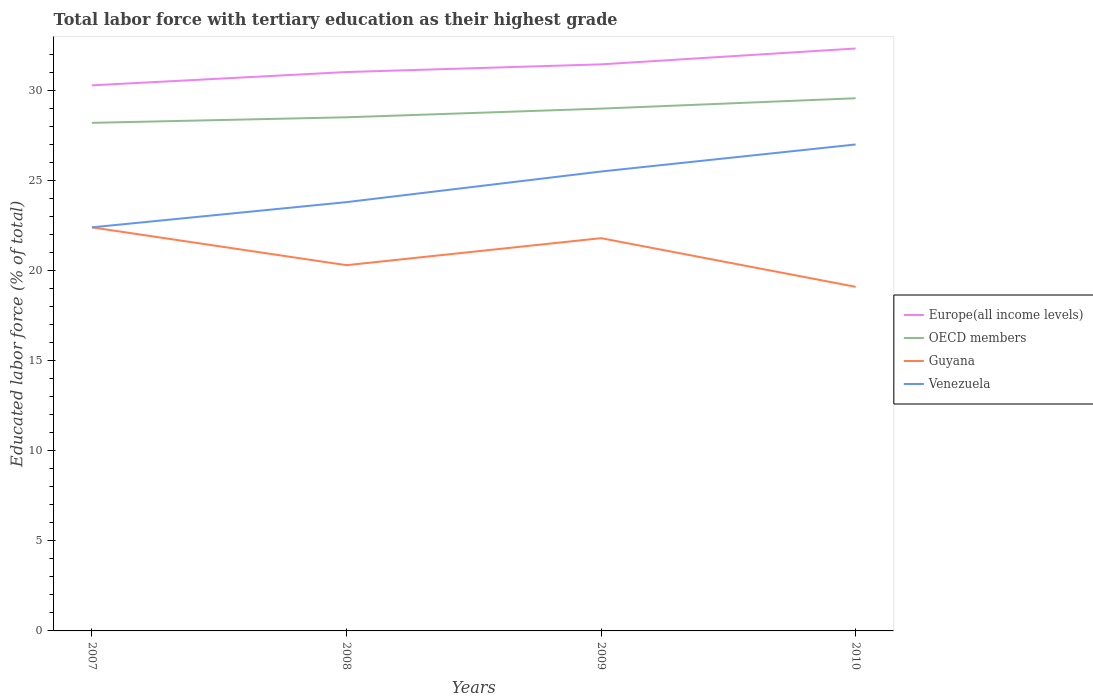Does the line corresponding to OECD members intersect with the line corresponding to Guyana?
Your answer should be very brief. No. Is the number of lines equal to the number of legend labels?
Keep it short and to the point. Yes. Across all years, what is the maximum percentage of male labor force with tertiary education in Guyana?
Ensure brevity in your answer.  19.1. In which year was the percentage of male labor force with tertiary education in Guyana maximum?
Ensure brevity in your answer.  2010. What is the total percentage of male labor force with tertiary education in Guyana in the graph?
Provide a short and direct response. 2.1. What is the difference between the highest and the second highest percentage of male labor force with tertiary education in OECD members?
Your response must be concise. 1.36. What is the difference between the highest and the lowest percentage of male labor force with tertiary education in Guyana?
Ensure brevity in your answer.  2. How many lines are there?
Offer a very short reply. 4. What is the difference between two consecutive major ticks on the Y-axis?
Your response must be concise. 5. Are the values on the major ticks of Y-axis written in scientific E-notation?
Give a very brief answer. No. Does the graph contain grids?
Offer a very short reply. No. Where does the legend appear in the graph?
Provide a succinct answer. Center right. How many legend labels are there?
Your response must be concise. 4. How are the legend labels stacked?
Make the answer very short. Vertical. What is the title of the graph?
Offer a very short reply. Total labor force with tertiary education as their highest grade. What is the label or title of the Y-axis?
Give a very brief answer. Educated labor force (% of total). What is the Educated labor force (% of total) in Europe(all income levels) in 2007?
Offer a very short reply. 30.28. What is the Educated labor force (% of total) of OECD members in 2007?
Give a very brief answer. 28.2. What is the Educated labor force (% of total) in Guyana in 2007?
Offer a terse response. 22.4. What is the Educated labor force (% of total) in Venezuela in 2007?
Provide a short and direct response. 22.4. What is the Educated labor force (% of total) in Europe(all income levels) in 2008?
Make the answer very short. 31.02. What is the Educated labor force (% of total) in OECD members in 2008?
Your answer should be very brief. 28.51. What is the Educated labor force (% of total) in Guyana in 2008?
Your response must be concise. 20.3. What is the Educated labor force (% of total) in Venezuela in 2008?
Your answer should be compact. 23.8. What is the Educated labor force (% of total) in Europe(all income levels) in 2009?
Provide a succinct answer. 31.45. What is the Educated labor force (% of total) of OECD members in 2009?
Provide a succinct answer. 28.99. What is the Educated labor force (% of total) in Guyana in 2009?
Your response must be concise. 21.8. What is the Educated labor force (% of total) of Venezuela in 2009?
Give a very brief answer. 25.5. What is the Educated labor force (% of total) of Europe(all income levels) in 2010?
Give a very brief answer. 32.33. What is the Educated labor force (% of total) of OECD members in 2010?
Keep it short and to the point. 29.57. What is the Educated labor force (% of total) of Guyana in 2010?
Ensure brevity in your answer.  19.1. Across all years, what is the maximum Educated labor force (% of total) in Europe(all income levels)?
Offer a very short reply. 32.33. Across all years, what is the maximum Educated labor force (% of total) in OECD members?
Give a very brief answer. 29.57. Across all years, what is the maximum Educated labor force (% of total) in Guyana?
Offer a very short reply. 22.4. Across all years, what is the maximum Educated labor force (% of total) of Venezuela?
Your response must be concise. 27. Across all years, what is the minimum Educated labor force (% of total) of Europe(all income levels)?
Give a very brief answer. 30.28. Across all years, what is the minimum Educated labor force (% of total) of OECD members?
Offer a terse response. 28.2. Across all years, what is the minimum Educated labor force (% of total) of Guyana?
Keep it short and to the point. 19.1. Across all years, what is the minimum Educated labor force (% of total) in Venezuela?
Ensure brevity in your answer.  22.4. What is the total Educated labor force (% of total) of Europe(all income levels) in the graph?
Provide a short and direct response. 125.08. What is the total Educated labor force (% of total) of OECD members in the graph?
Offer a very short reply. 115.27. What is the total Educated labor force (% of total) in Guyana in the graph?
Your answer should be very brief. 83.6. What is the total Educated labor force (% of total) in Venezuela in the graph?
Your answer should be very brief. 98.7. What is the difference between the Educated labor force (% of total) of Europe(all income levels) in 2007 and that in 2008?
Ensure brevity in your answer.  -0.74. What is the difference between the Educated labor force (% of total) of OECD members in 2007 and that in 2008?
Offer a terse response. -0.31. What is the difference between the Educated labor force (% of total) in Europe(all income levels) in 2007 and that in 2009?
Offer a very short reply. -1.16. What is the difference between the Educated labor force (% of total) of OECD members in 2007 and that in 2009?
Give a very brief answer. -0.79. What is the difference between the Educated labor force (% of total) of Europe(all income levels) in 2007 and that in 2010?
Provide a succinct answer. -2.04. What is the difference between the Educated labor force (% of total) in OECD members in 2007 and that in 2010?
Make the answer very short. -1.36. What is the difference between the Educated labor force (% of total) of Europe(all income levels) in 2008 and that in 2009?
Your answer should be very brief. -0.43. What is the difference between the Educated labor force (% of total) in OECD members in 2008 and that in 2009?
Keep it short and to the point. -0.48. What is the difference between the Educated labor force (% of total) in Guyana in 2008 and that in 2009?
Your answer should be very brief. -1.5. What is the difference between the Educated labor force (% of total) of Venezuela in 2008 and that in 2009?
Offer a very short reply. -1.7. What is the difference between the Educated labor force (% of total) of Europe(all income levels) in 2008 and that in 2010?
Make the answer very short. -1.31. What is the difference between the Educated labor force (% of total) of OECD members in 2008 and that in 2010?
Provide a short and direct response. -1.06. What is the difference between the Educated labor force (% of total) in Europe(all income levels) in 2009 and that in 2010?
Keep it short and to the point. -0.88. What is the difference between the Educated labor force (% of total) in OECD members in 2009 and that in 2010?
Your answer should be very brief. -0.58. What is the difference between the Educated labor force (% of total) in Guyana in 2009 and that in 2010?
Your answer should be very brief. 2.7. What is the difference between the Educated labor force (% of total) of Venezuela in 2009 and that in 2010?
Provide a short and direct response. -1.5. What is the difference between the Educated labor force (% of total) of Europe(all income levels) in 2007 and the Educated labor force (% of total) of OECD members in 2008?
Your response must be concise. 1.77. What is the difference between the Educated labor force (% of total) in Europe(all income levels) in 2007 and the Educated labor force (% of total) in Guyana in 2008?
Keep it short and to the point. 9.98. What is the difference between the Educated labor force (% of total) of Europe(all income levels) in 2007 and the Educated labor force (% of total) of Venezuela in 2008?
Your answer should be compact. 6.48. What is the difference between the Educated labor force (% of total) of OECD members in 2007 and the Educated labor force (% of total) of Guyana in 2008?
Ensure brevity in your answer.  7.9. What is the difference between the Educated labor force (% of total) in OECD members in 2007 and the Educated labor force (% of total) in Venezuela in 2008?
Provide a succinct answer. 4.4. What is the difference between the Educated labor force (% of total) in Guyana in 2007 and the Educated labor force (% of total) in Venezuela in 2008?
Offer a terse response. -1.4. What is the difference between the Educated labor force (% of total) of Europe(all income levels) in 2007 and the Educated labor force (% of total) of OECD members in 2009?
Offer a very short reply. 1.29. What is the difference between the Educated labor force (% of total) in Europe(all income levels) in 2007 and the Educated labor force (% of total) in Guyana in 2009?
Your response must be concise. 8.48. What is the difference between the Educated labor force (% of total) in Europe(all income levels) in 2007 and the Educated labor force (% of total) in Venezuela in 2009?
Make the answer very short. 4.78. What is the difference between the Educated labor force (% of total) of OECD members in 2007 and the Educated labor force (% of total) of Guyana in 2009?
Your answer should be compact. 6.4. What is the difference between the Educated labor force (% of total) in OECD members in 2007 and the Educated labor force (% of total) in Venezuela in 2009?
Keep it short and to the point. 2.7. What is the difference between the Educated labor force (% of total) in Europe(all income levels) in 2007 and the Educated labor force (% of total) in OECD members in 2010?
Provide a succinct answer. 0.72. What is the difference between the Educated labor force (% of total) of Europe(all income levels) in 2007 and the Educated labor force (% of total) of Guyana in 2010?
Provide a succinct answer. 11.18. What is the difference between the Educated labor force (% of total) of Europe(all income levels) in 2007 and the Educated labor force (% of total) of Venezuela in 2010?
Provide a short and direct response. 3.28. What is the difference between the Educated labor force (% of total) of OECD members in 2007 and the Educated labor force (% of total) of Guyana in 2010?
Your answer should be compact. 9.1. What is the difference between the Educated labor force (% of total) in OECD members in 2007 and the Educated labor force (% of total) in Venezuela in 2010?
Offer a terse response. 1.2. What is the difference between the Educated labor force (% of total) in Europe(all income levels) in 2008 and the Educated labor force (% of total) in OECD members in 2009?
Make the answer very short. 2.03. What is the difference between the Educated labor force (% of total) in Europe(all income levels) in 2008 and the Educated labor force (% of total) in Guyana in 2009?
Provide a succinct answer. 9.22. What is the difference between the Educated labor force (% of total) in Europe(all income levels) in 2008 and the Educated labor force (% of total) in Venezuela in 2009?
Offer a very short reply. 5.52. What is the difference between the Educated labor force (% of total) of OECD members in 2008 and the Educated labor force (% of total) of Guyana in 2009?
Your response must be concise. 6.71. What is the difference between the Educated labor force (% of total) in OECD members in 2008 and the Educated labor force (% of total) in Venezuela in 2009?
Make the answer very short. 3.01. What is the difference between the Educated labor force (% of total) of Guyana in 2008 and the Educated labor force (% of total) of Venezuela in 2009?
Your answer should be compact. -5.2. What is the difference between the Educated labor force (% of total) of Europe(all income levels) in 2008 and the Educated labor force (% of total) of OECD members in 2010?
Offer a terse response. 1.45. What is the difference between the Educated labor force (% of total) of Europe(all income levels) in 2008 and the Educated labor force (% of total) of Guyana in 2010?
Provide a succinct answer. 11.92. What is the difference between the Educated labor force (% of total) in Europe(all income levels) in 2008 and the Educated labor force (% of total) in Venezuela in 2010?
Your answer should be compact. 4.02. What is the difference between the Educated labor force (% of total) in OECD members in 2008 and the Educated labor force (% of total) in Guyana in 2010?
Ensure brevity in your answer.  9.41. What is the difference between the Educated labor force (% of total) of OECD members in 2008 and the Educated labor force (% of total) of Venezuela in 2010?
Your answer should be compact. 1.51. What is the difference between the Educated labor force (% of total) of Guyana in 2008 and the Educated labor force (% of total) of Venezuela in 2010?
Give a very brief answer. -6.7. What is the difference between the Educated labor force (% of total) of Europe(all income levels) in 2009 and the Educated labor force (% of total) of OECD members in 2010?
Your answer should be very brief. 1.88. What is the difference between the Educated labor force (% of total) of Europe(all income levels) in 2009 and the Educated labor force (% of total) of Guyana in 2010?
Your answer should be very brief. 12.35. What is the difference between the Educated labor force (% of total) of Europe(all income levels) in 2009 and the Educated labor force (% of total) of Venezuela in 2010?
Your response must be concise. 4.45. What is the difference between the Educated labor force (% of total) in OECD members in 2009 and the Educated labor force (% of total) in Guyana in 2010?
Ensure brevity in your answer.  9.89. What is the difference between the Educated labor force (% of total) in OECD members in 2009 and the Educated labor force (% of total) in Venezuela in 2010?
Provide a short and direct response. 1.99. What is the difference between the Educated labor force (% of total) in Guyana in 2009 and the Educated labor force (% of total) in Venezuela in 2010?
Keep it short and to the point. -5.2. What is the average Educated labor force (% of total) in Europe(all income levels) per year?
Make the answer very short. 31.27. What is the average Educated labor force (% of total) in OECD members per year?
Provide a succinct answer. 28.82. What is the average Educated labor force (% of total) of Guyana per year?
Make the answer very short. 20.9. What is the average Educated labor force (% of total) of Venezuela per year?
Your answer should be compact. 24.68. In the year 2007, what is the difference between the Educated labor force (% of total) in Europe(all income levels) and Educated labor force (% of total) in OECD members?
Your answer should be very brief. 2.08. In the year 2007, what is the difference between the Educated labor force (% of total) of Europe(all income levels) and Educated labor force (% of total) of Guyana?
Offer a very short reply. 7.88. In the year 2007, what is the difference between the Educated labor force (% of total) of Europe(all income levels) and Educated labor force (% of total) of Venezuela?
Your response must be concise. 7.88. In the year 2007, what is the difference between the Educated labor force (% of total) of OECD members and Educated labor force (% of total) of Guyana?
Offer a terse response. 5.8. In the year 2007, what is the difference between the Educated labor force (% of total) in OECD members and Educated labor force (% of total) in Venezuela?
Make the answer very short. 5.8. In the year 2008, what is the difference between the Educated labor force (% of total) in Europe(all income levels) and Educated labor force (% of total) in OECD members?
Offer a very short reply. 2.51. In the year 2008, what is the difference between the Educated labor force (% of total) of Europe(all income levels) and Educated labor force (% of total) of Guyana?
Your response must be concise. 10.72. In the year 2008, what is the difference between the Educated labor force (% of total) in Europe(all income levels) and Educated labor force (% of total) in Venezuela?
Your response must be concise. 7.22. In the year 2008, what is the difference between the Educated labor force (% of total) of OECD members and Educated labor force (% of total) of Guyana?
Keep it short and to the point. 8.21. In the year 2008, what is the difference between the Educated labor force (% of total) of OECD members and Educated labor force (% of total) of Venezuela?
Ensure brevity in your answer.  4.71. In the year 2009, what is the difference between the Educated labor force (% of total) of Europe(all income levels) and Educated labor force (% of total) of OECD members?
Make the answer very short. 2.46. In the year 2009, what is the difference between the Educated labor force (% of total) in Europe(all income levels) and Educated labor force (% of total) in Guyana?
Ensure brevity in your answer.  9.65. In the year 2009, what is the difference between the Educated labor force (% of total) in Europe(all income levels) and Educated labor force (% of total) in Venezuela?
Ensure brevity in your answer.  5.95. In the year 2009, what is the difference between the Educated labor force (% of total) of OECD members and Educated labor force (% of total) of Guyana?
Provide a succinct answer. 7.19. In the year 2009, what is the difference between the Educated labor force (% of total) of OECD members and Educated labor force (% of total) of Venezuela?
Your response must be concise. 3.49. In the year 2009, what is the difference between the Educated labor force (% of total) in Guyana and Educated labor force (% of total) in Venezuela?
Your response must be concise. -3.7. In the year 2010, what is the difference between the Educated labor force (% of total) of Europe(all income levels) and Educated labor force (% of total) of OECD members?
Your answer should be compact. 2.76. In the year 2010, what is the difference between the Educated labor force (% of total) in Europe(all income levels) and Educated labor force (% of total) in Guyana?
Your response must be concise. 13.23. In the year 2010, what is the difference between the Educated labor force (% of total) of Europe(all income levels) and Educated labor force (% of total) of Venezuela?
Ensure brevity in your answer.  5.33. In the year 2010, what is the difference between the Educated labor force (% of total) in OECD members and Educated labor force (% of total) in Guyana?
Give a very brief answer. 10.47. In the year 2010, what is the difference between the Educated labor force (% of total) in OECD members and Educated labor force (% of total) in Venezuela?
Keep it short and to the point. 2.57. In the year 2010, what is the difference between the Educated labor force (% of total) in Guyana and Educated labor force (% of total) in Venezuela?
Your response must be concise. -7.9. What is the ratio of the Educated labor force (% of total) in Europe(all income levels) in 2007 to that in 2008?
Give a very brief answer. 0.98. What is the ratio of the Educated labor force (% of total) in OECD members in 2007 to that in 2008?
Your answer should be very brief. 0.99. What is the ratio of the Educated labor force (% of total) of Guyana in 2007 to that in 2008?
Offer a very short reply. 1.1. What is the ratio of the Educated labor force (% of total) in OECD members in 2007 to that in 2009?
Your response must be concise. 0.97. What is the ratio of the Educated labor force (% of total) in Guyana in 2007 to that in 2009?
Your response must be concise. 1.03. What is the ratio of the Educated labor force (% of total) of Venezuela in 2007 to that in 2009?
Provide a succinct answer. 0.88. What is the ratio of the Educated labor force (% of total) of Europe(all income levels) in 2007 to that in 2010?
Provide a short and direct response. 0.94. What is the ratio of the Educated labor force (% of total) in OECD members in 2007 to that in 2010?
Provide a succinct answer. 0.95. What is the ratio of the Educated labor force (% of total) of Guyana in 2007 to that in 2010?
Provide a short and direct response. 1.17. What is the ratio of the Educated labor force (% of total) in Venezuela in 2007 to that in 2010?
Your response must be concise. 0.83. What is the ratio of the Educated labor force (% of total) in Europe(all income levels) in 2008 to that in 2009?
Make the answer very short. 0.99. What is the ratio of the Educated labor force (% of total) of OECD members in 2008 to that in 2009?
Your answer should be very brief. 0.98. What is the ratio of the Educated labor force (% of total) in Guyana in 2008 to that in 2009?
Give a very brief answer. 0.93. What is the ratio of the Educated labor force (% of total) in Venezuela in 2008 to that in 2009?
Make the answer very short. 0.93. What is the ratio of the Educated labor force (% of total) of Europe(all income levels) in 2008 to that in 2010?
Provide a short and direct response. 0.96. What is the ratio of the Educated labor force (% of total) of Guyana in 2008 to that in 2010?
Give a very brief answer. 1.06. What is the ratio of the Educated labor force (% of total) of Venezuela in 2008 to that in 2010?
Give a very brief answer. 0.88. What is the ratio of the Educated labor force (% of total) in Europe(all income levels) in 2009 to that in 2010?
Ensure brevity in your answer.  0.97. What is the ratio of the Educated labor force (% of total) in OECD members in 2009 to that in 2010?
Offer a very short reply. 0.98. What is the ratio of the Educated labor force (% of total) in Guyana in 2009 to that in 2010?
Offer a very short reply. 1.14. What is the ratio of the Educated labor force (% of total) of Venezuela in 2009 to that in 2010?
Provide a succinct answer. 0.94. What is the difference between the highest and the second highest Educated labor force (% of total) in Europe(all income levels)?
Your answer should be compact. 0.88. What is the difference between the highest and the second highest Educated labor force (% of total) of OECD members?
Keep it short and to the point. 0.58. What is the difference between the highest and the second highest Educated labor force (% of total) in Guyana?
Your response must be concise. 0.6. What is the difference between the highest and the lowest Educated labor force (% of total) in Europe(all income levels)?
Provide a succinct answer. 2.04. What is the difference between the highest and the lowest Educated labor force (% of total) of OECD members?
Offer a very short reply. 1.36. What is the difference between the highest and the lowest Educated labor force (% of total) in Guyana?
Your answer should be compact. 3.3. What is the difference between the highest and the lowest Educated labor force (% of total) in Venezuela?
Provide a succinct answer. 4.6. 